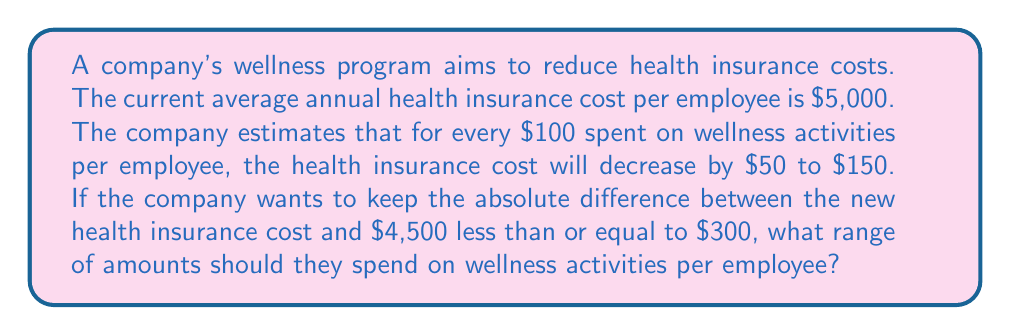Can you answer this question? Let's approach this step-by-step:

1) Let $x$ be the amount spent on wellness activities per employee (in hundreds of dollars).

2) The decrease in health insurance cost can be represented as $50x$ to $150x$.

3) The new health insurance cost will be $5000 - 50x$ to $5000 - 150x$.

4) We want the absolute difference between the new cost and $4500 to be at most $300. This can be expressed as an absolute value inequality:

   $$|5000 - 50x - 4500| \leq 300$$ and $$|5000 - 150x - 4500| \leq 300$$

5) Simplifying:
   
   $$|500 - 50x| \leq 300$$ and $$|500 - 150x| \leq 300$$

6) Solving the first inequality:
   
   $-300 \leq 500 - 50x \leq 300$
   $-800 \leq -50x \leq -200$
   $16 \geq x \geq 4$

7) Solving the second inequality:
   
   $-300 \leq 500 - 150x \leq 300$
   $-800 \leq -150x \leq -200$
   $5.33 \geq x \geq 1.33$

8) Combining the results, we get:
   
   $5.33 \geq x \geq 4$

9) Converting back to dollars:
   
   $533 \geq 100x \geq 400$

Therefore, the company should spend between $400 and $533 on wellness activities per employee.
Answer: $400 to $533 